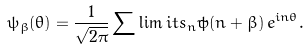<formula> <loc_0><loc_0><loc_500><loc_500>\psi _ { \beta } ( \theta ) = \frac { 1 } { \sqrt { 2 \pi } } \sum \lim i t s _ { n } { \tilde { \psi } } ( n + \beta ) \, e ^ { i n \theta } .</formula> 